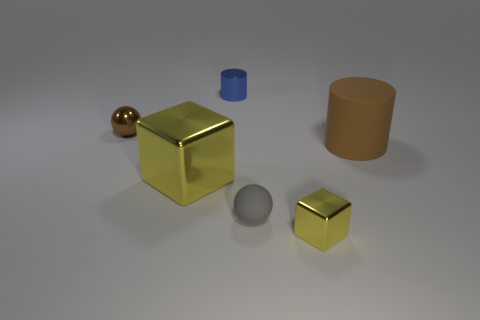Do the small object that is behind the brown sphere and the large metallic object have the same shape?
Your answer should be very brief. No. There is a metallic cylinder that is the same size as the gray matte object; what color is it?
Ensure brevity in your answer.  Blue. How many metal things are there?
Offer a very short reply. 4. Is the big object that is on the left side of the small blue metal object made of the same material as the tiny cube?
Make the answer very short. Yes. What is the thing that is both left of the blue object and in front of the large brown cylinder made of?
Ensure brevity in your answer.  Metal. What is the size of the thing that is the same color as the large block?
Your answer should be compact. Small. What is the material of the ball that is behind the brown thing that is in front of the brown metal ball?
Provide a succinct answer. Metal. There is a yellow thing that is behind the sphere that is to the right of the ball to the left of the big metallic thing; what is its size?
Your answer should be compact. Large. What number of small brown spheres are the same material as the tiny gray ball?
Make the answer very short. 0. There is a matte object on the left side of the yellow thing on the right side of the blue metallic cylinder; what color is it?
Offer a terse response. Gray. 